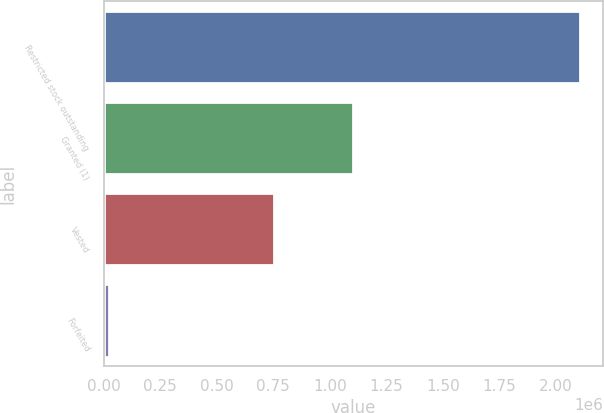Convert chart. <chart><loc_0><loc_0><loc_500><loc_500><bar_chart><fcel>Restricted stock outstanding<fcel>Granted (1)<fcel>Vested<fcel>Forfeited<nl><fcel>2.10491e+06<fcel>1.10059e+06<fcel>751201<fcel>21904<nl></chart> 